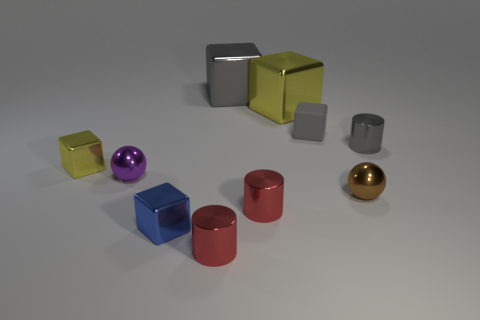How many metal objects are gray cylinders or spheres?
Offer a terse response. 3. Is the shape of the matte object the same as the gray metal thing that is in front of the big yellow shiny thing?
Provide a short and direct response. No. Is the number of shiny spheres on the left side of the gray metallic cube greater than the number of cubes behind the small gray cylinder?
Your response must be concise. No. Are there any big yellow cubes that are to the right of the yellow cube that is on the right side of the metallic block that is behind the large yellow metallic block?
Provide a succinct answer. No. Is the shape of the red shiny object that is in front of the small blue shiny cube the same as  the tiny gray metal object?
Your response must be concise. Yes. Is the number of tiny gray cubes that are left of the small purple object less than the number of metallic objects behind the tiny gray cylinder?
Your answer should be very brief. Yes. What material is the brown ball?
Your response must be concise. Metal. There is a small matte cube; is its color the same as the big object behind the big yellow metallic block?
Your answer should be very brief. Yes. How many small purple shiny spheres are right of the blue object?
Your answer should be compact. 0. Is the number of big metallic blocks to the right of the tiny brown shiny ball less than the number of small red objects?
Ensure brevity in your answer.  Yes. 